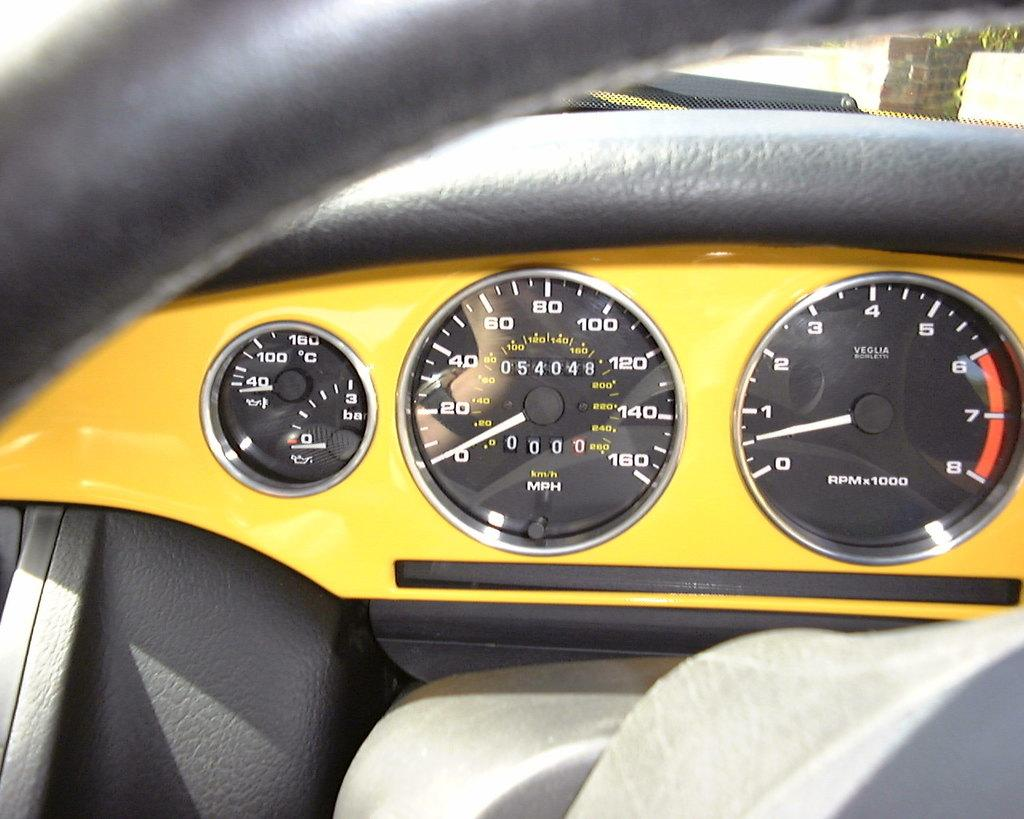What is the main subject of the image? The main subject of the image is a vehicle's odometer. What else can be seen in the image besides the odometer? The steering is visible in the image. What colors are used for the vehicle's interior in the image? The color scheme of the vehicle's interior is black and yellow. What type of substance is the deer attracted to in the image? There is no deer present in the image, so it is not possible to determine what substance might attract it. 